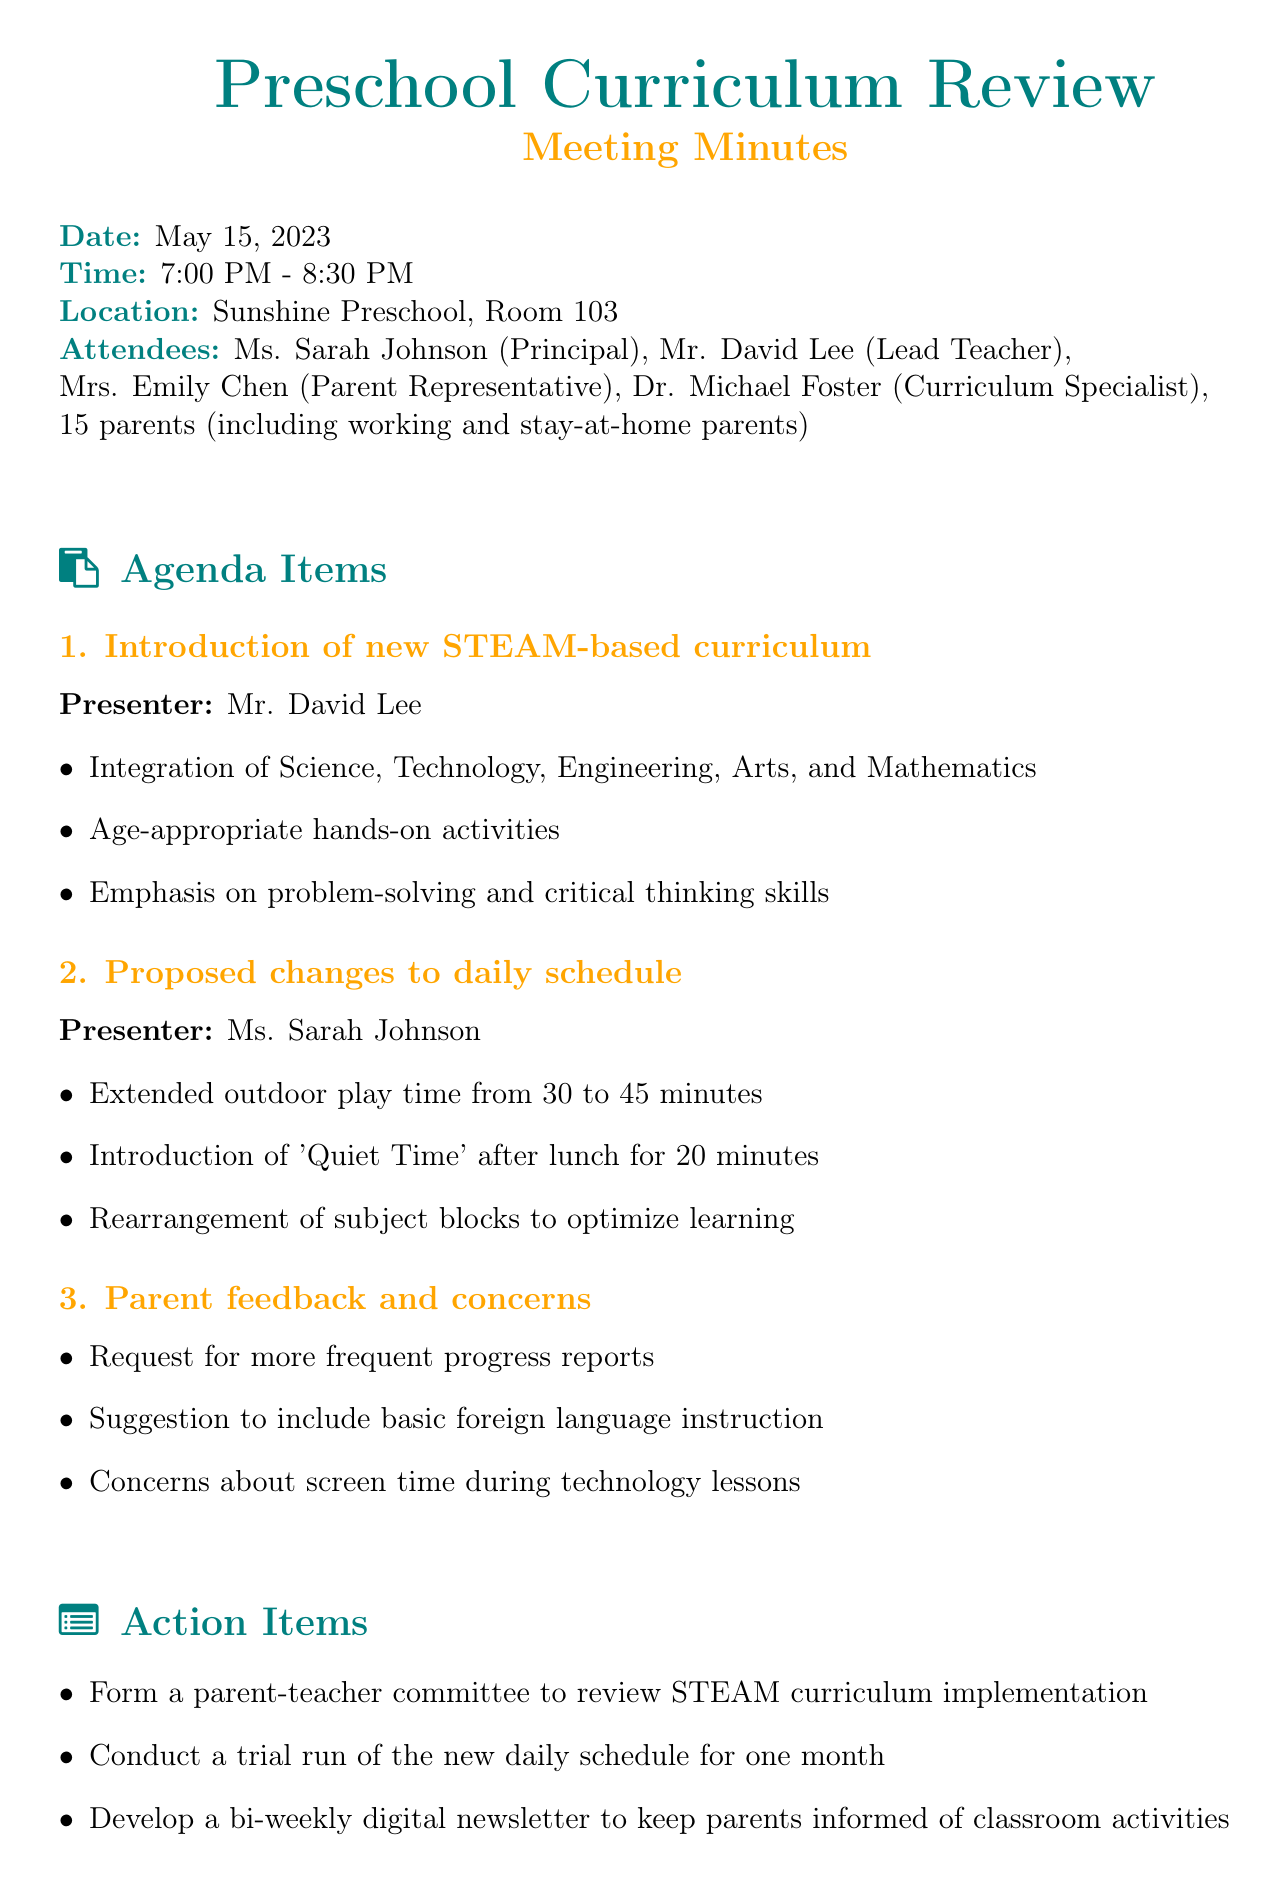What date was the meeting held? The meeting date is explicitly stated in the document as May 15, 2023.
Answer: May 15, 2023 Who is the Lead Teacher? The role of the Lead Teacher is assigned to Mr. David Lee as mentioned in the attendee list.
Answer: Mr. David Lee What is one proposed change to the daily schedule? The document outlines several proposed changes including extended outdoor play time.
Answer: Extended outdoor play time How long will the 'Quiet Time' be after lunch? The document specifies the duration of 'Quiet Time' as 20 minutes.
Answer: 20 minutes What was a parent concern regarding technology lessons? The document mentions parent concerns specifically about screen time during technology lessons.
Answer: Screen time How many parents attended the meeting? The attendee list states that there were a total of 15 parents present at the meeting.
Answer: 15 parents What is one action item from the meeting? The document lists several action items, including forming a parent-teacher committee.
Answer: Form a parent-teacher committee When is the follow-up meeting scheduled? The follow-up meeting date is provided in the next steps section as June 12, 2023.
Answer: June 12, 2023 When will the new curriculum be implemented? The implementation date for the new curriculum is stated as September 1, 2023.
Answer: September 1, 2023 